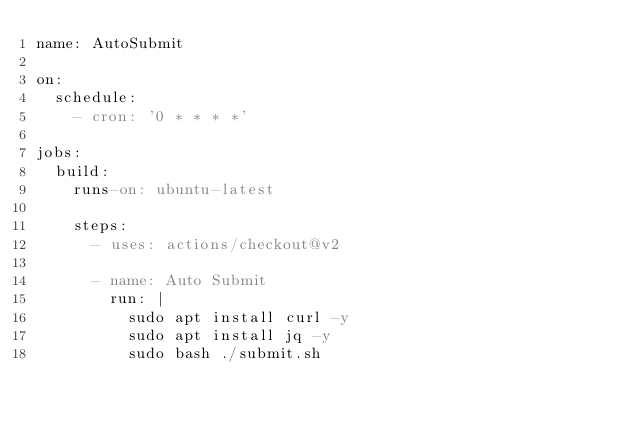<code> <loc_0><loc_0><loc_500><loc_500><_YAML_>name: AutoSubmit

on:
  schedule:
    - cron: '0 * * * *'

jobs:
  build:
    runs-on: ubuntu-latest

    steps:
      - uses: actions/checkout@v2

      - name: Auto Submit
        run: |
          sudo apt install curl -y
          sudo apt install jq -y
          sudo bash ./submit.sh
</code> 